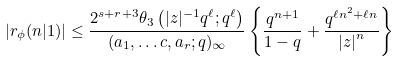<formula> <loc_0><loc_0><loc_500><loc_500>| r _ { \phi } ( n | 1 ) | & \leq \frac { 2 ^ { s + r + 3 } \theta _ { 3 } \left ( | z | ^ { - 1 } q ^ { \ell } ; q ^ { \ell } \right ) } { ( a _ { 1 } , \dots c , a _ { r } ; q ) _ { \infty } } \left \{ \frac { q ^ { n + 1 } } { 1 - q } + \frac { q ^ { \ell n ^ { 2 } + \ell n } } { \left | z \right | ^ { n } } \right \}</formula> 